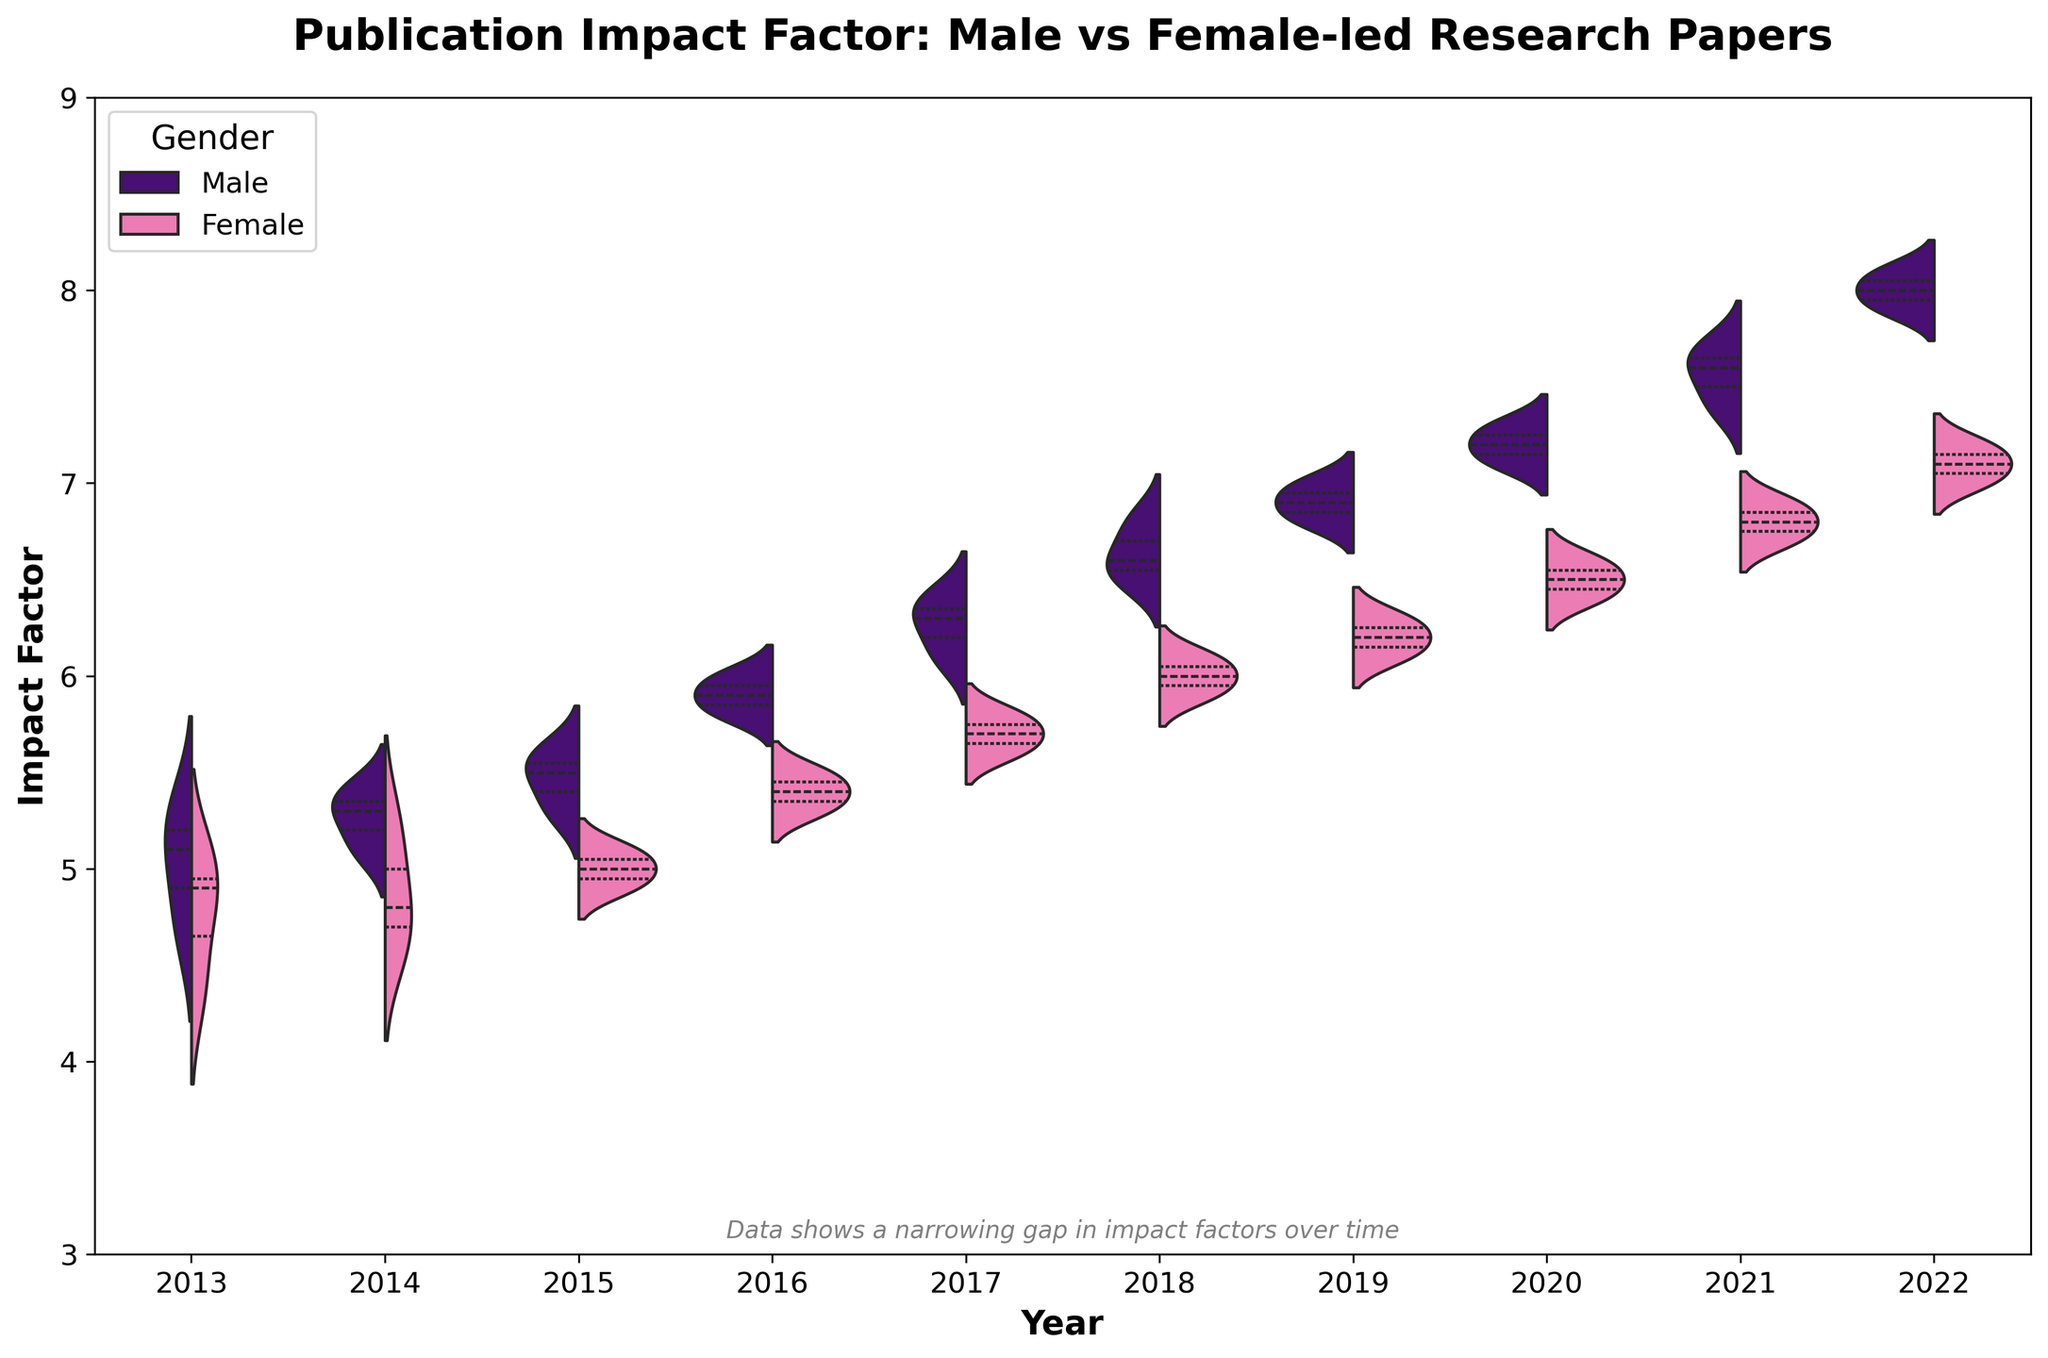What is the title of the figure? The title is typically displayed at the top of the plot. In this case, it reads "Publication Impact Factor: Male vs Female-led Research Papers".
Answer: Publication Impact Factor: Male vs Female-led Research Papers What are the x-axis and y-axis labels? The labels are found on the horizontal and vertical axes of the plot. The x-axis label is "Year" and the y-axis label is "Impact Factor".
Answer: Year (x-axis), Impact Factor (y-axis) What colors represent male and female-led research papers? The distinct colors used in the violin plot differentiate between male and female-led research papers. According to the palette, male-led papers are represented in purple and female-led papers in pink.
Answer: Purple for male, pink for female Which year shows the lowest impact factor range for female-led papers? By examining the spread and positions of the violins for female-led papers, we see that the year 2013 shows the lowest impact factor range.
Answer: 2013 How does the median impact factor for male and female-led papers compare in 2016? By looking at the quartile lines inside each violin for the year 2016, the median (the thickest line in the center) for male-led papers is higher than that of female-led papers.
Answer: Male median is higher What trend is observed in the median impact factor for female-led papers from 2013 to 2022? Observing the central lines in the female violins across the years, the median impact factor shows a gradually increasing trend from 2013 to 2022, indicating improving impact over time.
Answer: Increasing trend In which year is the difference between the median impact factors of male and female-led papers the smallest? By examining the space between the median lines of male and female-led papers across years, the gap is smallest in the later years, particularly around 2021 and 2022. However, precise determination could be slightly subjective.
Answer: 2021 or 2022 Is there a year where the distribution of impact factors for female-led papers intersects with male-led papers? Analyzing the overlapping regions of the violins for each year, especially looking at interquartile ranges, the distributions intersect in almost all years but prominently around 2018 to 2022.
Answer: Yes, notably around 2018-2022 How has the impact factor range of male-led papers evolved over the decade? By observing the spread of the violins for male-led papers from 2013 to 2022, the impact factor range has generally increased, indicating a broader distribution in the latter years.
Answer: Increased range 